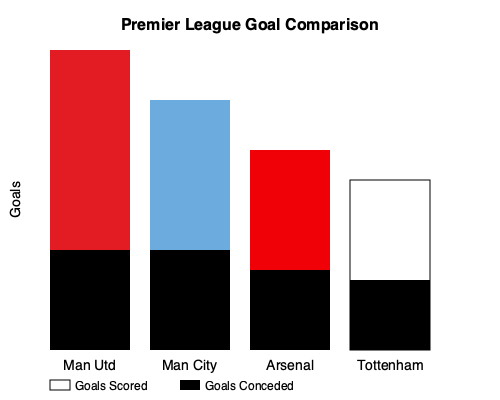Based on the stacked bar chart comparing goals scored and conceded for Premier League teams, calculate the goal difference for Manchester United and determine how it compares to Manchester City's goal difference. To solve this problem, we need to follow these steps:

1. Calculate Manchester United's goal difference:
   - Goals scored: The red bar height is 200 units (300 - 100)
   - Goals conceded: The black bar height is 100 units
   - Goal difference = Goals scored - Goals conceded
   - Manchester United's goal difference = 200 - 100 = 100

2. Calculate Manchester City's goal difference:
   - Goals scored: The light blue bar height is 150 units (250 - 100)
   - Goals conceded: The black bar height is 100 units
   - Goal difference = Goals scored - Goals conceded
   - Manchester City's goal difference = 150 - 100 = 50

3. Compare the two goal differences:
   - Manchester United's goal difference: 100
   - Manchester City's goal difference: 50
   - Difference = 100 - 50 = 50

Therefore, Manchester United's goal difference is 50 goals better than Manchester City's.
Answer: Manchester United's goal difference is 50 goals better than Manchester City's. 